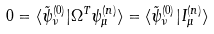<formula> <loc_0><loc_0><loc_500><loc_500>0 = \langle \tilde { \psi } _ { \nu } ^ { ( 0 ) } | \Omega ^ { T } \psi ^ { ( n ) } _ { \mu } \rangle = \langle \tilde { \psi } _ { \nu } ^ { ( 0 ) } | I _ { \mu } ^ { ( n ) } \rangle</formula> 